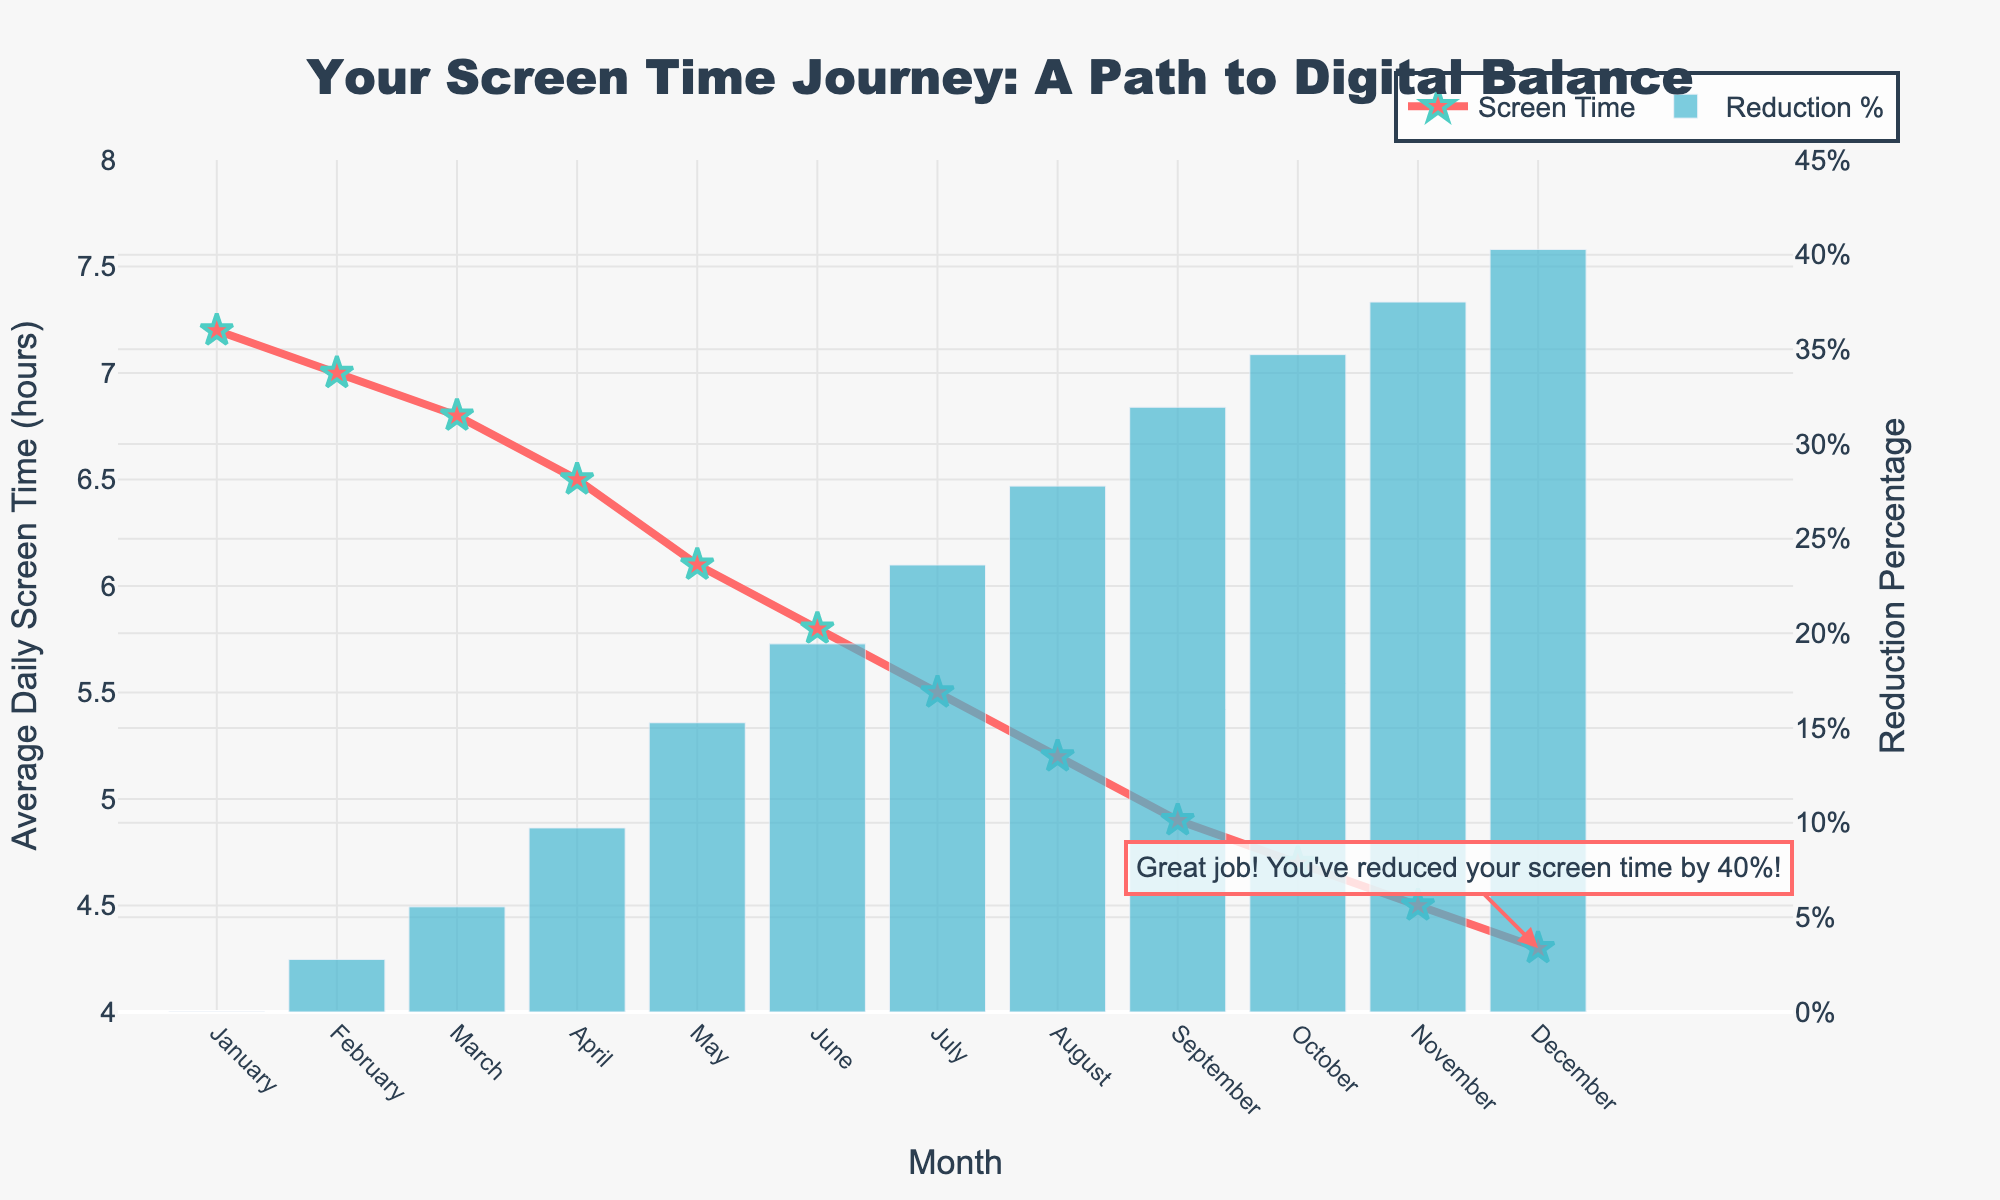What is the average daily screen time in June? To find the average daily screen time in June, refer to the value for June on the line plot.
Answer: 5.8 hours By what percentage did the average daily screen time decrease from January to December? First, calculate the initial screen time in January, which is 7.2 hours. Then, find the final screen time in December, which is 4.3 hours. The percentage decrease is calculated as ((7.2 - 4.3) / 7.2) * 100.
Answer: 40% Which month shows the greatest reduction in daily screen time compared to the previous month? Look at the line trend and compare the drops between consecutive months. The biggest drop is between May and June, where screen time reduced from 6.1 to 5.8 hours.
Answer: June What is the total reduction in average daily screen time from January to December in hours? Subtract the screen time in December (4.3 hours) from the screen time in January (7.2 hours).
Answer: 2.9 hours Which month has the third least average daily screen time? Rank the months based on their screen time. The third least is in October with 4.7 hours.
Answer: October How does the screen time in March compare to August? Check the values in March (6.8 hours) and August (5.2 hours). March has more screen time than August.
Answer: March has more What is the screen time in July, and how does it compare with that in September? The screen time in July is 5.5 hours, and in September it is 4.9 hours, making the screen time in July higher.
Answer: July is higher Between which two consecutive months did the average daily screen time go below 6 hours for the first time? Start from January and check each pair of consecutive months until the screen time first falls below 6 hours, which happens between April (6.5 hours) and May (6.1 hours).
Answer: April and May What is the overall trend of the average daily screen time over the year? The line plot shows a clear downward trend in screen time from January to December.
Answer: Downward trend Which color represents the reduction percentage in the chart? The bar chart depicts the reduction percentage and is shown in blue.
Answer: Blue 